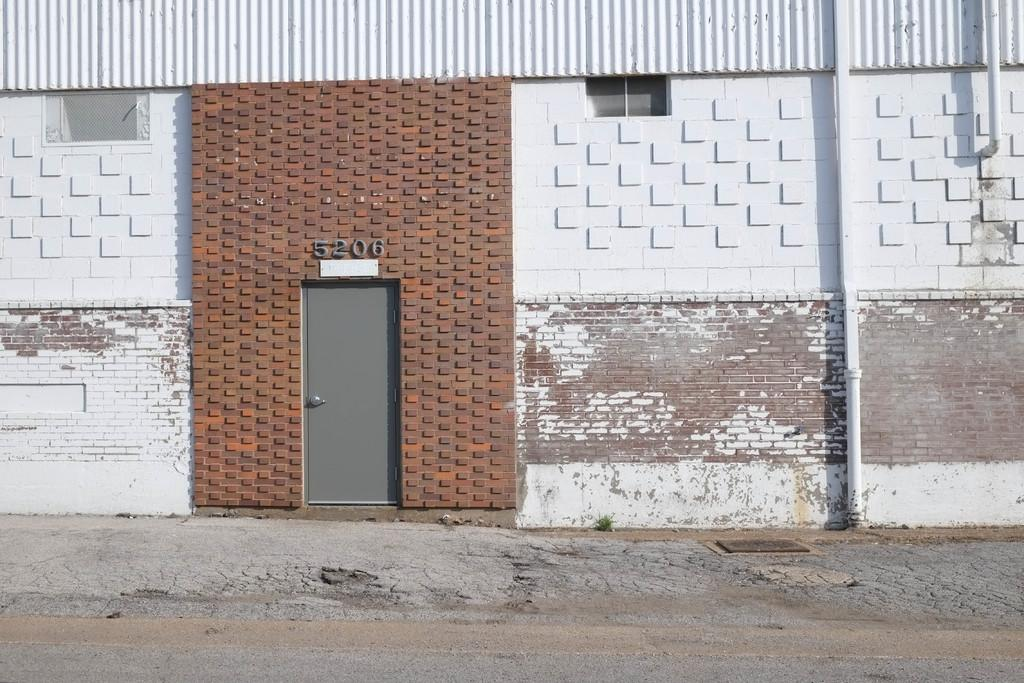What type of structure is present in the image? There is a building in the image. Can you describe any specific features of the building? There is a door in the image. Are there any written elements in the image? Yes, there are numbers written in the image. What can be seen in the foreground of the image? There is a path visible in the image. What type of sock is the building wearing in the image? There is no sock present in the image, as buildings do not wear socks. 